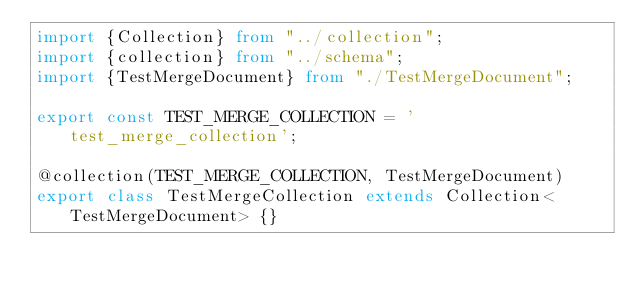<code> <loc_0><loc_0><loc_500><loc_500><_TypeScript_>import {Collection} from "../collection";
import {collection} from "../schema";
import {TestMergeDocument} from "./TestMergeDocument";

export const TEST_MERGE_COLLECTION = 'test_merge_collection';

@collection(TEST_MERGE_COLLECTION, TestMergeDocument)
export class TestMergeCollection extends Collection<TestMergeDocument> {}</code> 